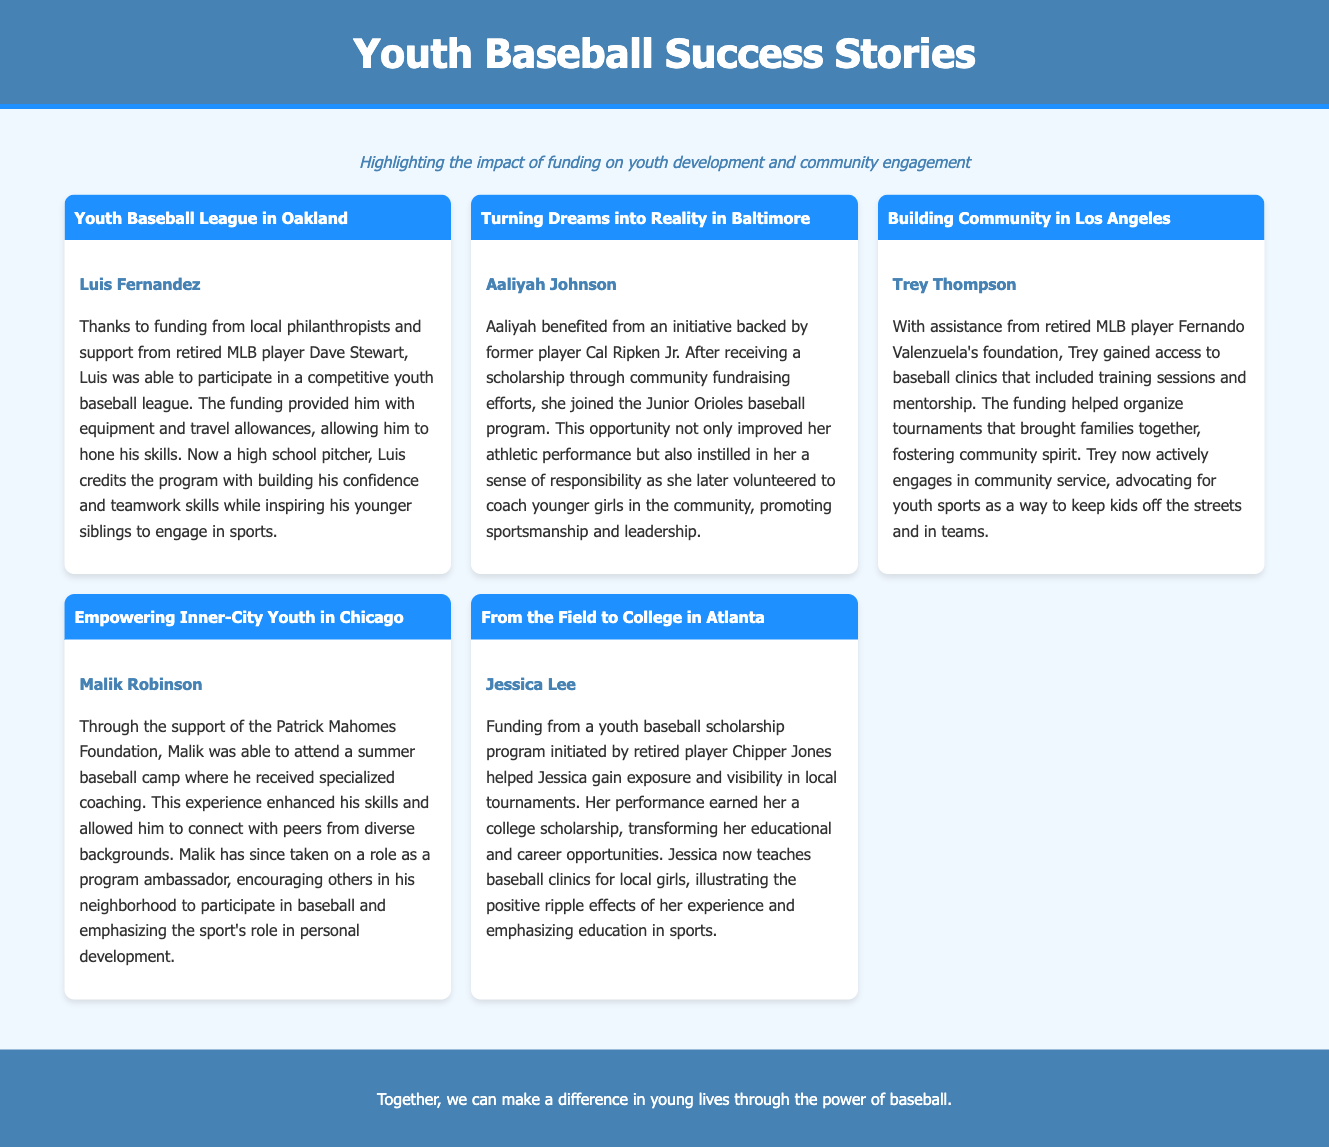What is the name of the program Luis Fernandez participated in? The program is referred to as a "competitive youth baseball league."
Answer: competitive youth baseball league Who supported Aaliyah Johnson’s initiative? Aaliyah benefited from the support of former player Cal Ripken Jr.
Answer: Cal Ripken Jr Which city is associated with Trey Thompson's success story? Trey Thompson's story is associated with Los Angeles.
Answer: Los Angeles What foundation helped Malik Robinson attend a summer baseball camp? Malik received support from the Patrick Mahomes Foundation.
Answer: Patrick Mahomes Foundation What critical skill did Jessica Lee gain from her experience? Jessica gained exposure and visibility in local tournaments.
Answer: exposure and visibility How did the funding impact Trey's community? It helped organize tournaments that fostered community spirit.
Answer: community spirit What role does Malik now have as a result of his experience? Malik has taken on a role as a program ambassador.
Answer: program ambassador What type of clinics does Jessica Lee teach now? Jessica now teaches baseball clinics for local girls.
Answer: baseball clinics for local girls What was a key aspect of Aaliyah’s personal development through baseball? Aaliyah developed a sense of responsibility.
Answer: sense of responsibility 